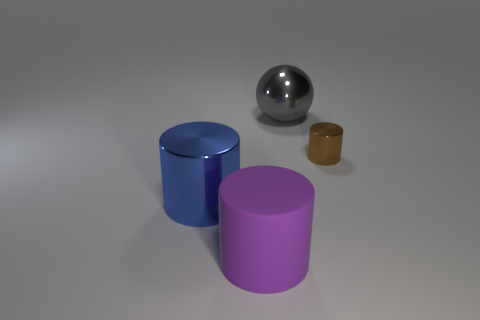Add 2 big purple things. How many objects exist? 6 Subtract all purple cylinders. How many cylinders are left? 2 Subtract all brown metallic cylinders. How many cylinders are left? 2 Subtract 0 purple balls. How many objects are left? 4 Subtract all balls. How many objects are left? 3 Subtract all purple cylinders. Subtract all purple balls. How many cylinders are left? 2 Subtract all brown blocks. How many red cylinders are left? 0 Subtract all large blue metallic objects. Subtract all large red cylinders. How many objects are left? 3 Add 1 big blue objects. How many big blue objects are left? 2 Add 2 brown shiny things. How many brown shiny things exist? 3 